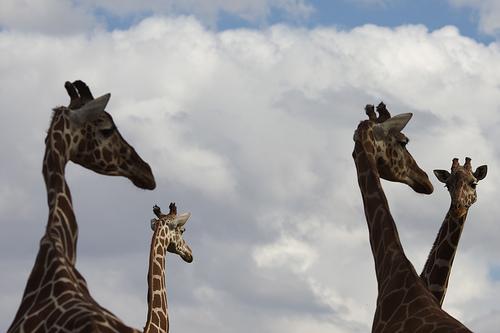Is it a clear day?
Short answer required. No. What type of vegetation is in the background?
Quick response, please. None. Is the sky overcast?
Concise answer only. Yes. How many giraffes are there?
Give a very brief answer. 4. Are the giraffes looking at something?
Keep it brief. Yes. What animals are these?
Write a very short answer. Giraffes. How many giraffes are in the photo?
Answer briefly. 4. 